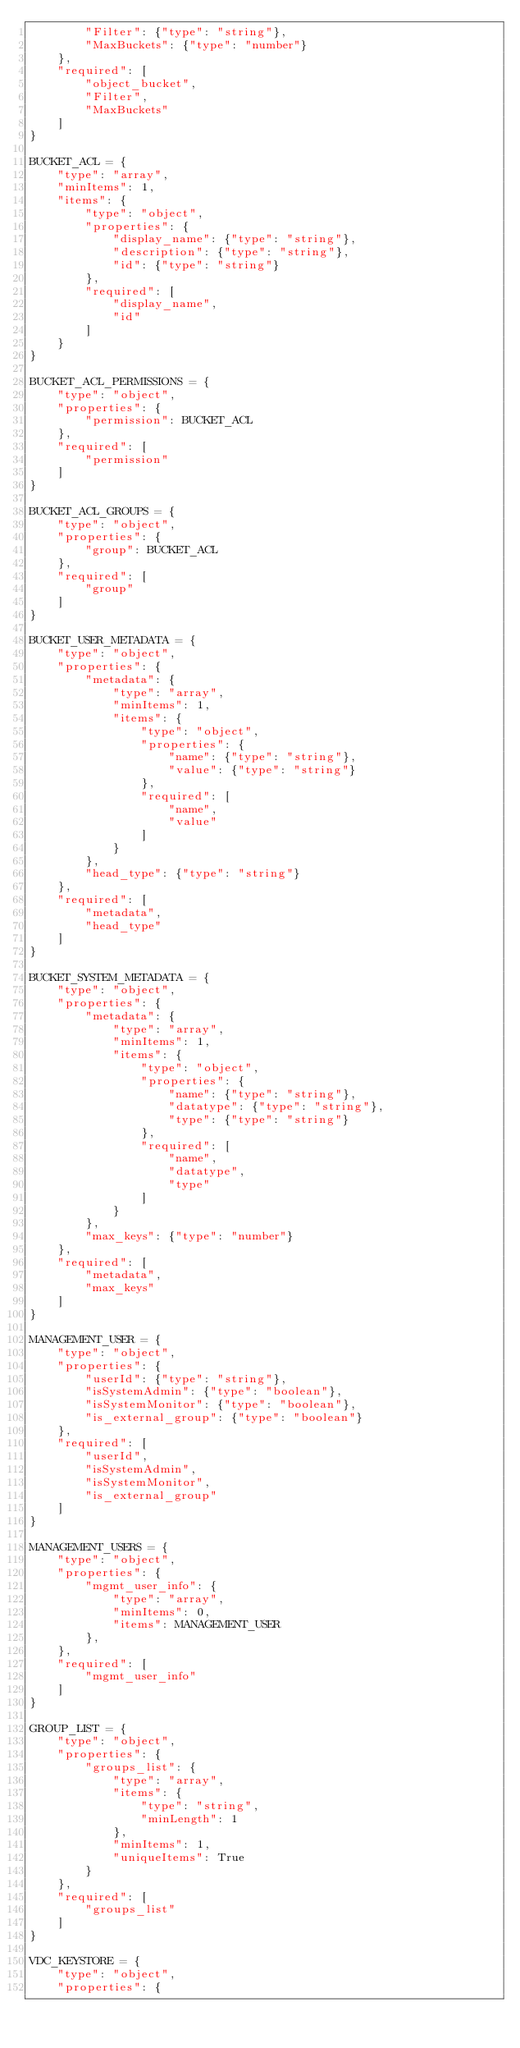Convert code to text. <code><loc_0><loc_0><loc_500><loc_500><_Python_>        "Filter": {"type": "string"},
        "MaxBuckets": {"type": "number"}
    },
    "required": [
        "object_bucket",
        "Filter",
        "MaxBuckets"
    ]
}

BUCKET_ACL = {
    "type": "array",
    "minItems": 1,
    "items": {
        "type": "object",
        "properties": {
            "display_name": {"type": "string"},
            "description": {"type": "string"},
            "id": {"type": "string"}
        },
        "required": [
            "display_name",
            "id"
        ]
    }
}

BUCKET_ACL_PERMISSIONS = {
    "type": "object",
    "properties": {
        "permission": BUCKET_ACL
    },
    "required": [
        "permission"
    ]
}

BUCKET_ACL_GROUPS = {
    "type": "object",
    "properties": {
        "group": BUCKET_ACL
    },
    "required": [
        "group"
    ]
}

BUCKET_USER_METADATA = {
    "type": "object",
    "properties": {
        "metadata": {
            "type": "array",
            "minItems": 1,
            "items": {
                "type": "object",
                "properties": {
                    "name": {"type": "string"},
                    "value": {"type": "string"}
                },
                "required": [
                    "name",
                    "value"
                ]
            }
        },
        "head_type": {"type": "string"}
    },
    "required": [
        "metadata",
        "head_type"
    ]
}

BUCKET_SYSTEM_METADATA = {
    "type": "object",
    "properties": {
        "metadata": {
            "type": "array",
            "minItems": 1,
            "items": {
                "type": "object",
                "properties": {
                    "name": {"type": "string"},
                    "datatype": {"type": "string"},
                    "type": {"type": "string"}
                },
                "required": [
                    "name",
                    "datatype",
                    "type"
                ]
            }
        },
        "max_keys": {"type": "number"}
    },
    "required": [
        "metadata",
        "max_keys"
    ]
}

MANAGEMENT_USER = {
    "type": "object",
    "properties": {
        "userId": {"type": "string"},
        "isSystemAdmin": {"type": "boolean"},
        "isSystemMonitor": {"type": "boolean"},
        "is_external_group": {"type": "boolean"}
    },
    "required": [
        "userId",
        "isSystemAdmin",
        "isSystemMonitor",
        "is_external_group"
    ]
}

MANAGEMENT_USERS = {
    "type": "object",
    "properties": {
        "mgmt_user_info": {
            "type": "array",
            "minItems": 0,
            "items": MANAGEMENT_USER
        },
    },
    "required": [
        "mgmt_user_info"
    ]
}

GROUP_LIST = {
    "type": "object",
    "properties": {
        "groups_list": {
            "type": "array",
            "items": {
                "type": "string",
                "minLength": 1
            },
            "minItems": 1,
            "uniqueItems": True
        }
    },
    "required": [
        "groups_list"
    ]
}

VDC_KEYSTORE = {
    "type": "object",
    "properties": {</code> 